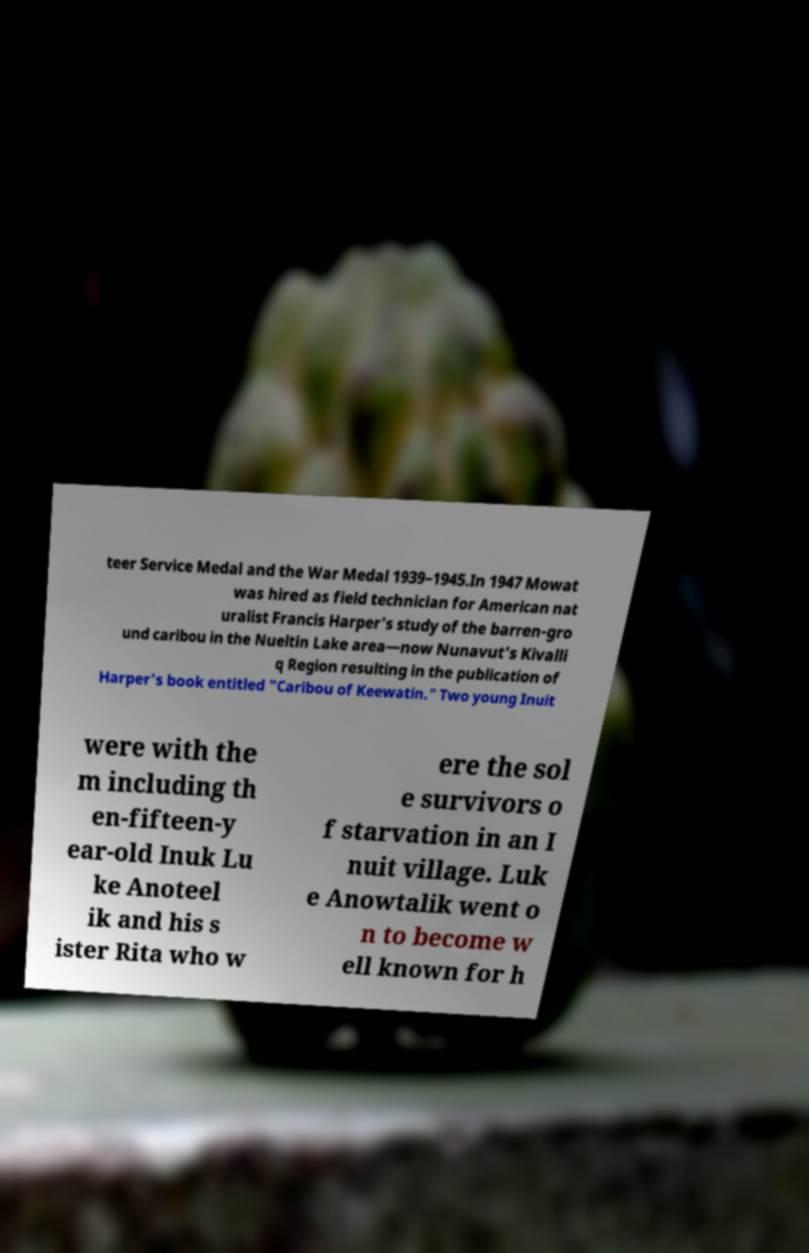What messages or text are displayed in this image? I need them in a readable, typed format. teer Service Medal and the War Medal 1939–1945.In 1947 Mowat was hired as field technician for American nat uralist Francis Harper's study of the barren-gro und caribou in the Nueltin Lake area—now Nunavut's Kivalli q Region resulting in the publication of Harper's book entitled "Caribou of Keewatin." Two young Inuit were with the m including th en-fifteen-y ear-old Inuk Lu ke Anoteel ik and his s ister Rita who w ere the sol e survivors o f starvation in an I nuit village. Luk e Anowtalik went o n to become w ell known for h 